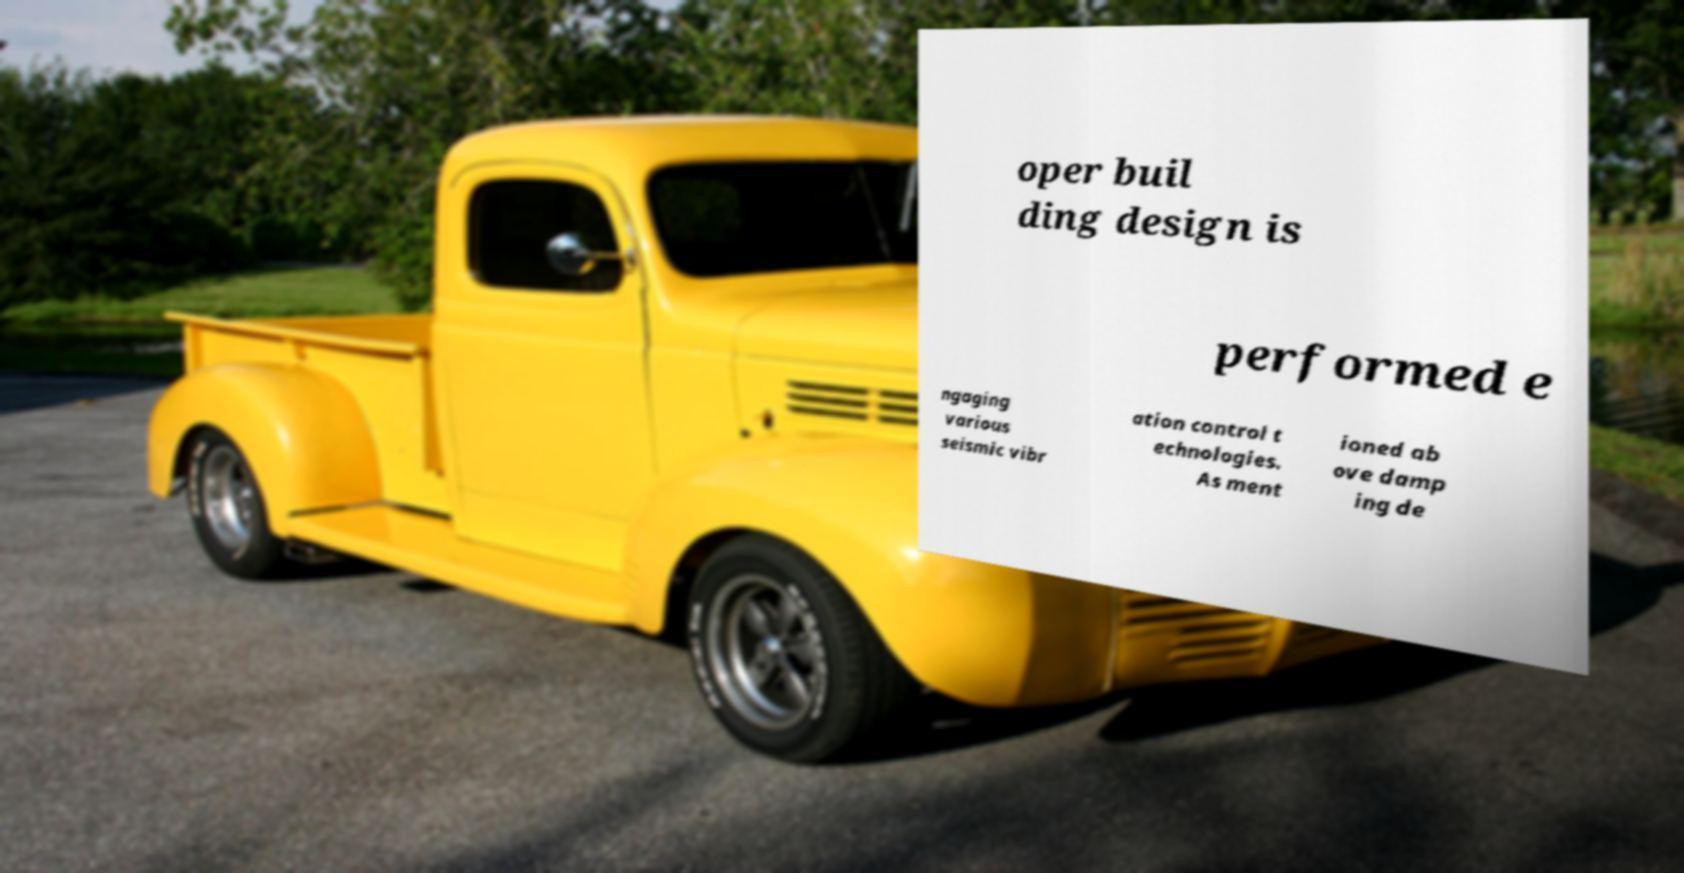Please identify and transcribe the text found in this image. oper buil ding design is performed e ngaging various seismic vibr ation control t echnologies. As ment ioned ab ove damp ing de 